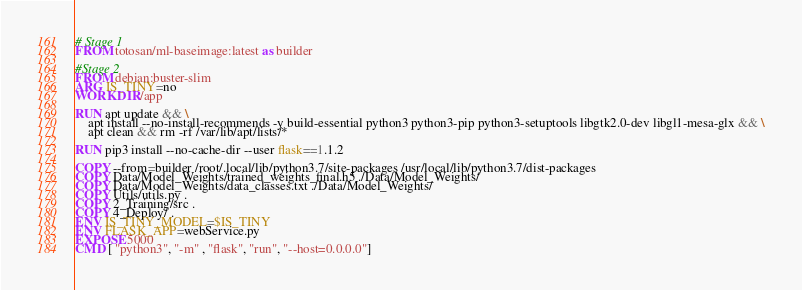<code> <loc_0><loc_0><loc_500><loc_500><_Dockerfile_># Stage 1 
FROM totosan/ml-baseimage:latest as builder

#Stage 2
FROM debian:buster-slim
ARG IS_TINY=no
WORKDIR /app

RUN apt update && \
    apt install --no-install-recommends -y build-essential python3 python3-pip python3-setuptools libgtk2.0-dev libgl1-mesa-glx && \
    apt clean && rm -rf /var/lib/apt/lists/*

RUN pip3 install --no-cache-dir --user flask==1.1.2

COPY --from=builder /root/.local/lib/python3.7/site-packages /usr/local/lib/python3.7/dist-packages
COPY Data/Model_Weights/trained_weights_final.h5 ./Data/Model_Weights/
COPY Data/Model_Weights/data_classes.txt ./Data/Model_Weights/
COPY Utils/utils.py .
COPY 2_Training/src .
COPY 4_Deploy/ .
ENV IS_TINY_MODEL=$IS_TINY
ENV FLASK_APP=webService.py
EXPOSE 5000
CMD [ "python3", "-m" , "flask", "run", "--host=0.0.0.0"]</code> 